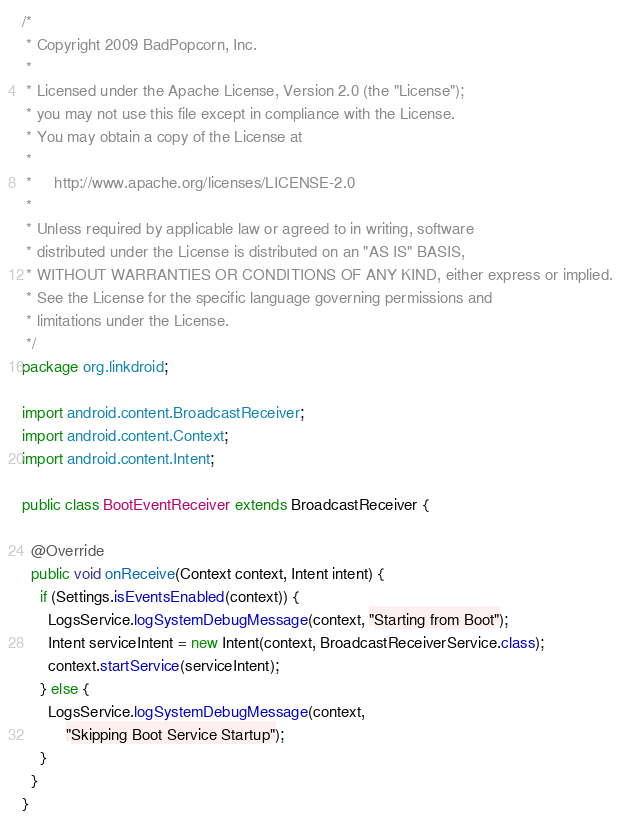Convert code to text. <code><loc_0><loc_0><loc_500><loc_500><_Java_>/*
 * Copyright 2009 BadPopcorn, Inc.
 *
 * Licensed under the Apache License, Version 2.0 (the "License");
 * you may not use this file except in compliance with the License.
 * You may obtain a copy of the License at
 *
 *     http://www.apache.org/licenses/LICENSE-2.0
 *
 * Unless required by applicable law or agreed to in writing, software
 * distributed under the License is distributed on an "AS IS" BASIS,
 * WITHOUT WARRANTIES OR CONDITIONS OF ANY KIND, either express or implied.
 * See the License for the specific language governing permissions and
 * limitations under the License.
 */
package org.linkdroid;

import android.content.BroadcastReceiver;
import android.content.Context;
import android.content.Intent;

public class BootEventReceiver extends BroadcastReceiver {

  @Override
  public void onReceive(Context context, Intent intent) {
    if (Settings.isEventsEnabled(context)) {
      LogsService.logSystemDebugMessage(context, "Starting from Boot");
      Intent serviceIntent = new Intent(context, BroadcastReceiverService.class);
      context.startService(serviceIntent);
    } else {
      LogsService.logSystemDebugMessage(context,
          "Skipping Boot Service Startup");
    }
  }
}
</code> 